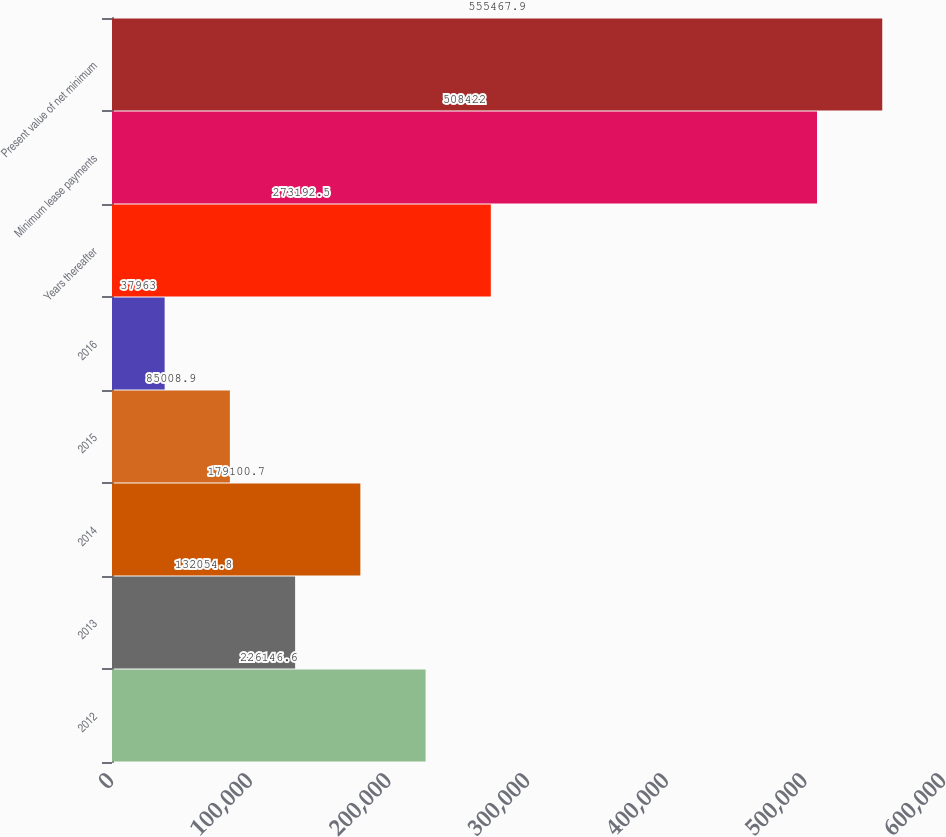Convert chart to OTSL. <chart><loc_0><loc_0><loc_500><loc_500><bar_chart><fcel>2012<fcel>2013<fcel>2014<fcel>2015<fcel>2016<fcel>Years thereafter<fcel>Minimum lease payments<fcel>Present value of net minimum<nl><fcel>226147<fcel>132055<fcel>179101<fcel>85008.9<fcel>37963<fcel>273192<fcel>508422<fcel>555468<nl></chart> 